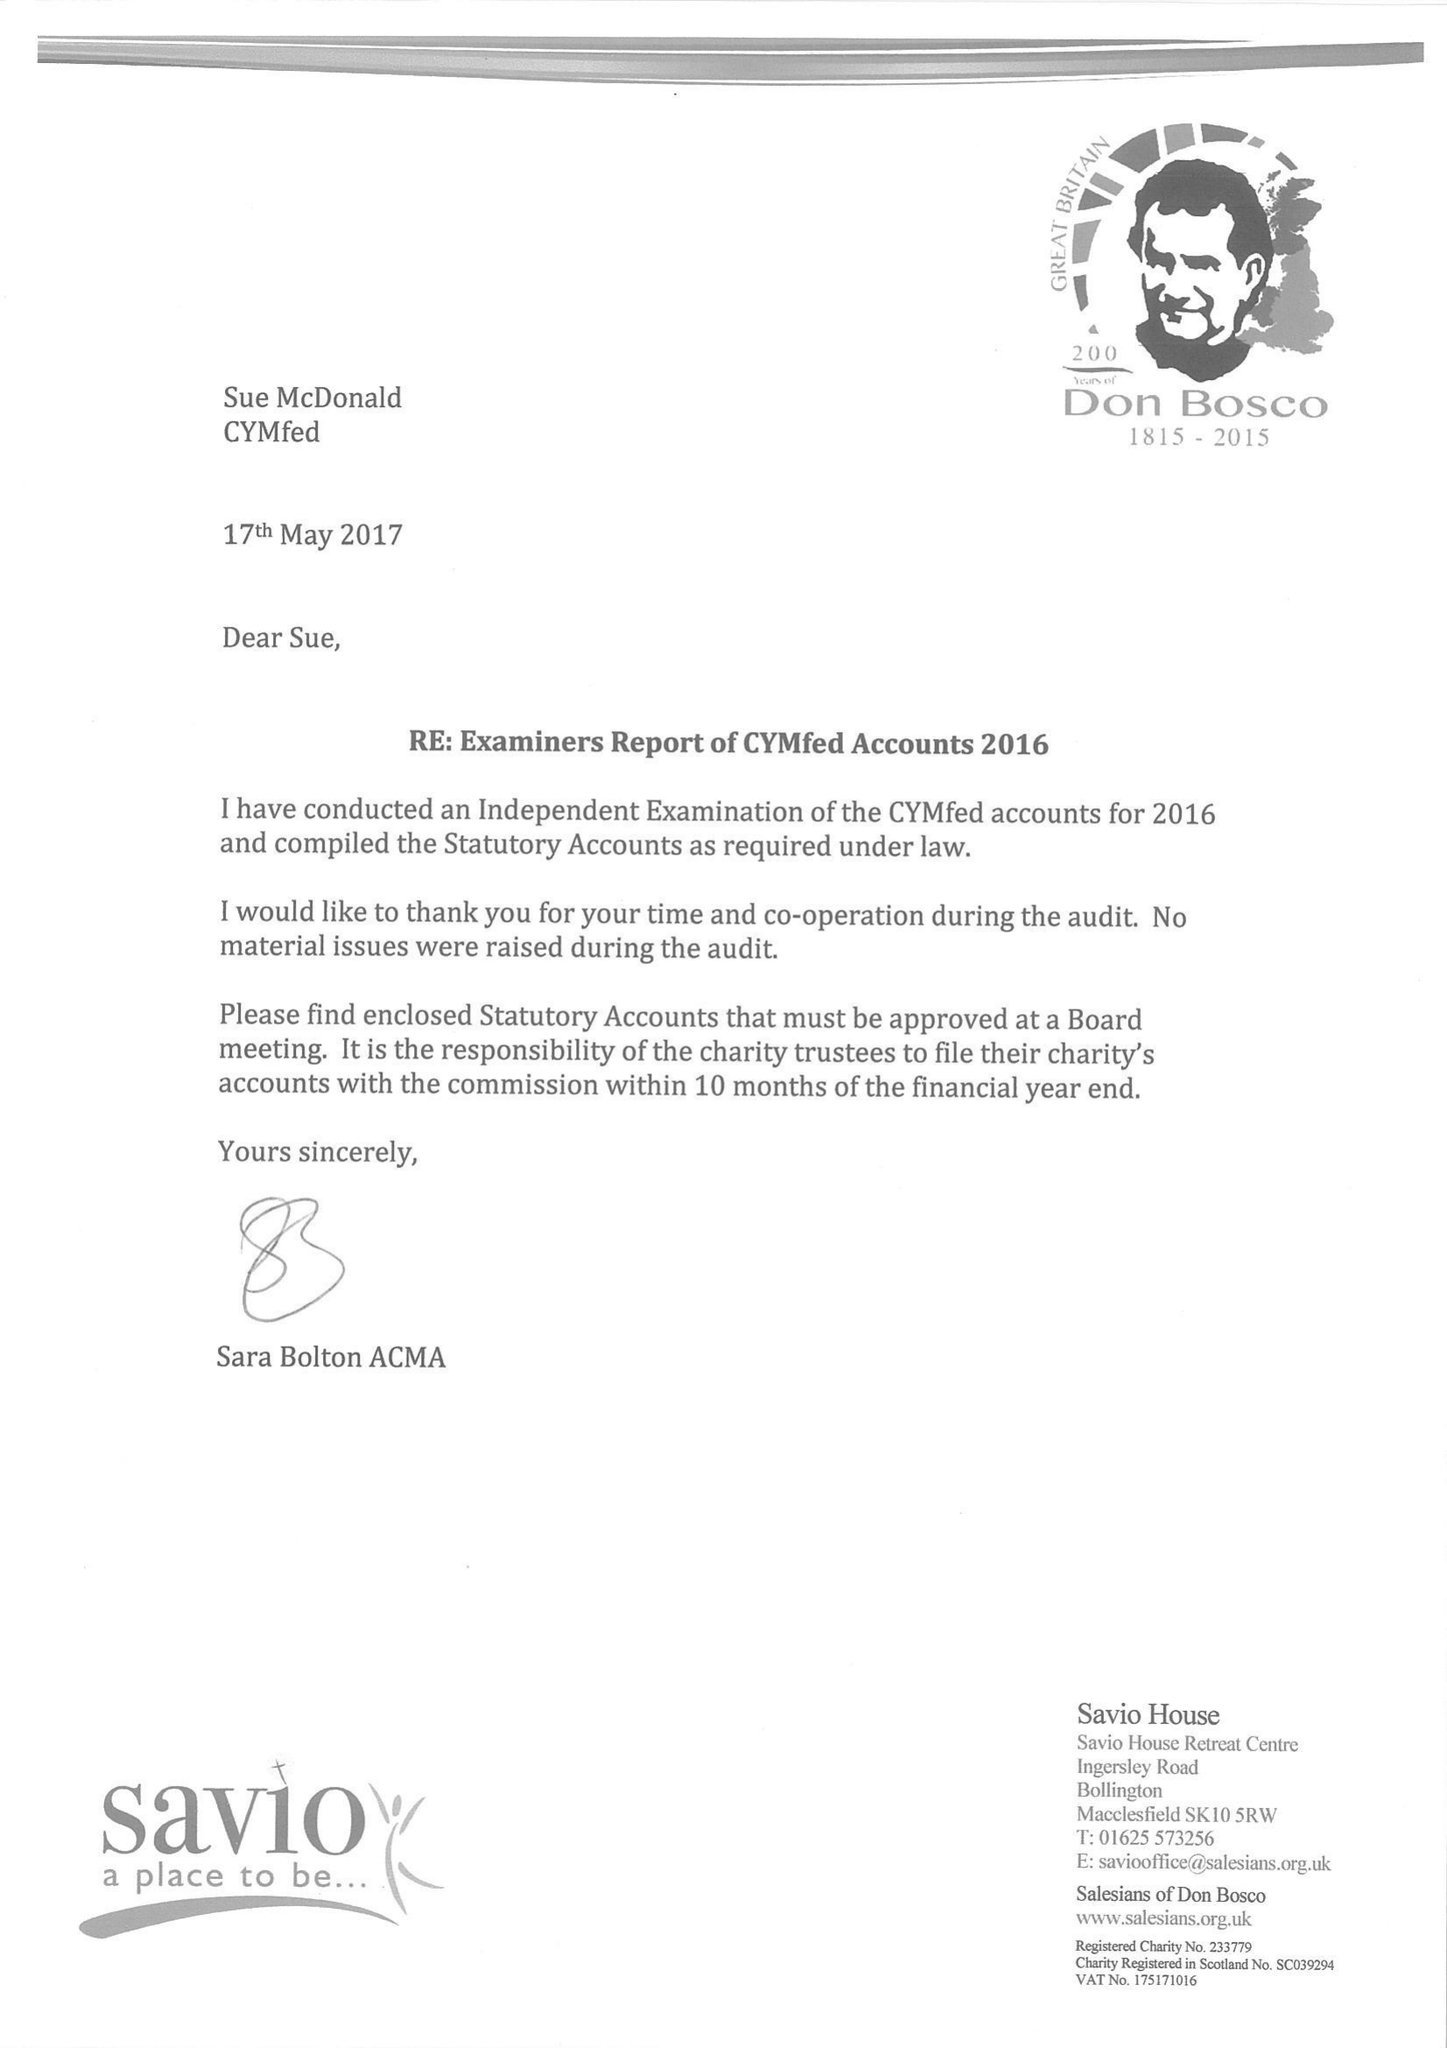What is the value for the spending_annually_in_british_pounds?
Answer the question using a single word or phrase. 51556.00 